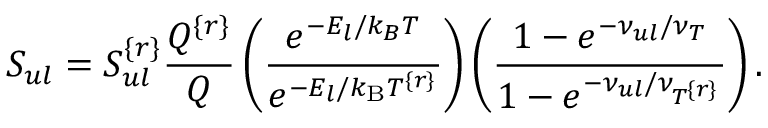<formula> <loc_0><loc_0><loc_500><loc_500>S _ { u l } = S _ { u l } ^ { \{ r \} } \frac { Q ^ { \{ r \} } } { Q } \left ( \frac { e ^ { - E _ { l } / k _ { B } T } } { e ^ { - E _ { l } / k _ { B } T ^ { \{ r \} } } } \right ) \left ( \frac { 1 - e ^ { - \nu _ { u l } / \nu _ { T } } } { 1 - e ^ { - \nu _ { u l } / \nu _ { T ^ { \{ r \} } } } } \right ) .</formula> 